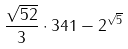<formula> <loc_0><loc_0><loc_500><loc_500>\frac { \sqrt { 5 2 } } { 3 } \cdot 3 4 1 - 2 ^ { \sqrt { 5 } }</formula> 